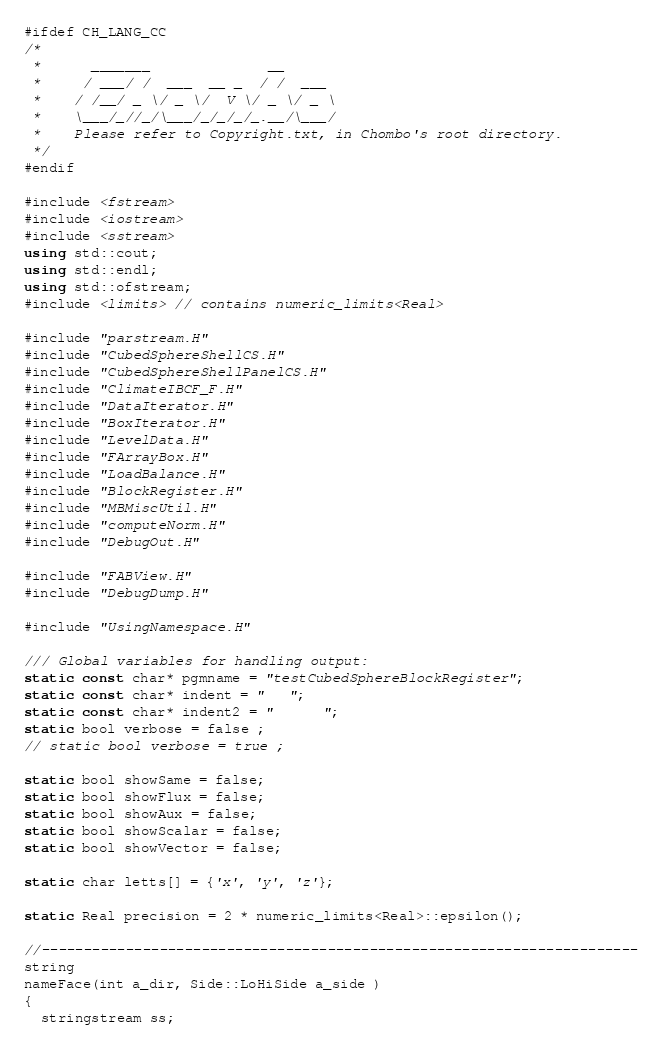<code> <loc_0><loc_0><loc_500><loc_500><_C++_>#ifdef CH_LANG_CC
/*
 *      _______              __
 *     / ___/ /  ___  __ _  / /  ___
 *    / /__/ _ \/ _ \/  V \/ _ \/ _ \
 *    \___/_//_/\___/_/_/_/_.__/\___/
 *    Please refer to Copyright.txt, in Chombo's root directory.
 */
#endif

#include <fstream>
#include <iostream>
#include <sstream>
using std::cout;
using std::endl;
using std::ofstream;
#include <limits> // contains numeric_limits<Real>

#include "parstream.H"
#include "CubedSphereShellCS.H"
#include "CubedSphereShellPanelCS.H"
#include "ClimateIBCF_F.H"
#include "DataIterator.H"
#include "BoxIterator.H"
#include "LevelData.H"
#include "FArrayBox.H"
#include "LoadBalance.H"
#include "BlockRegister.H"
#include "MBMiscUtil.H"
#include "computeNorm.H"
#include "DebugOut.H"

#include "FABView.H"
#include "DebugDump.H"

#include "UsingNamespace.H"

/// Global variables for handling output:
static const char* pgmname = "testCubedSphereBlockRegister";
static const char* indent = "   ";
static const char* indent2 = "      ";
static bool verbose = false ;
// static bool verbose = true ;

static bool showSame = false;
static bool showFlux = false;
static bool showAux = false;
static bool showScalar = false;
static bool showVector = false;

static char letts[] = {'x', 'y', 'z'};

static Real precision = 2 * numeric_limits<Real>::epsilon();

//-----------------------------------------------------------------------
string
nameFace(int a_dir, Side::LoHiSide a_side )
{
  stringstream ss;</code> 